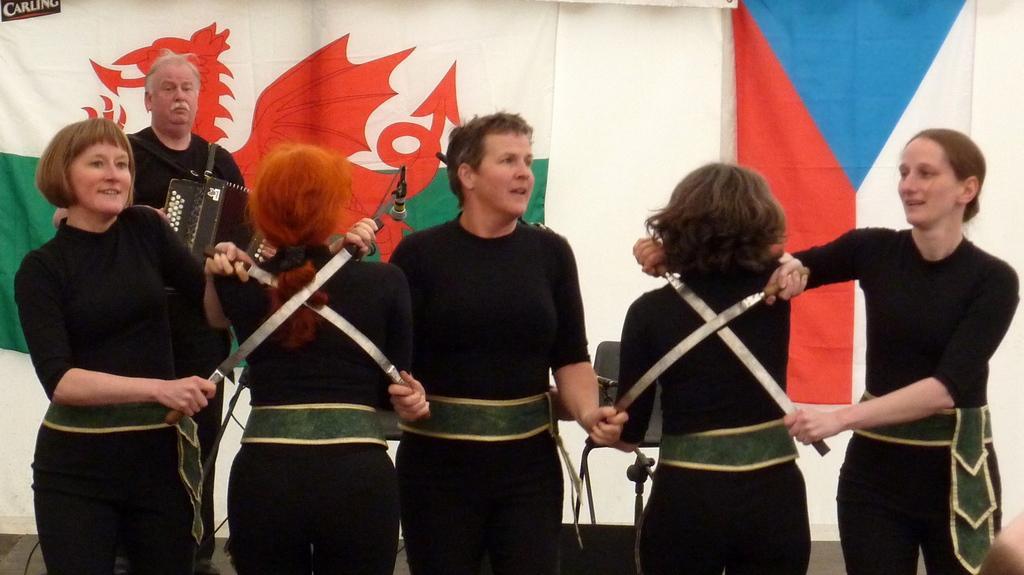Can you describe this image briefly? In front of the image there are a few people standing and holding swords in their hands, behind them there is a person standing and playing some musical instrument, beside him there are chairs and cables, behind him there are flags on the wall. 